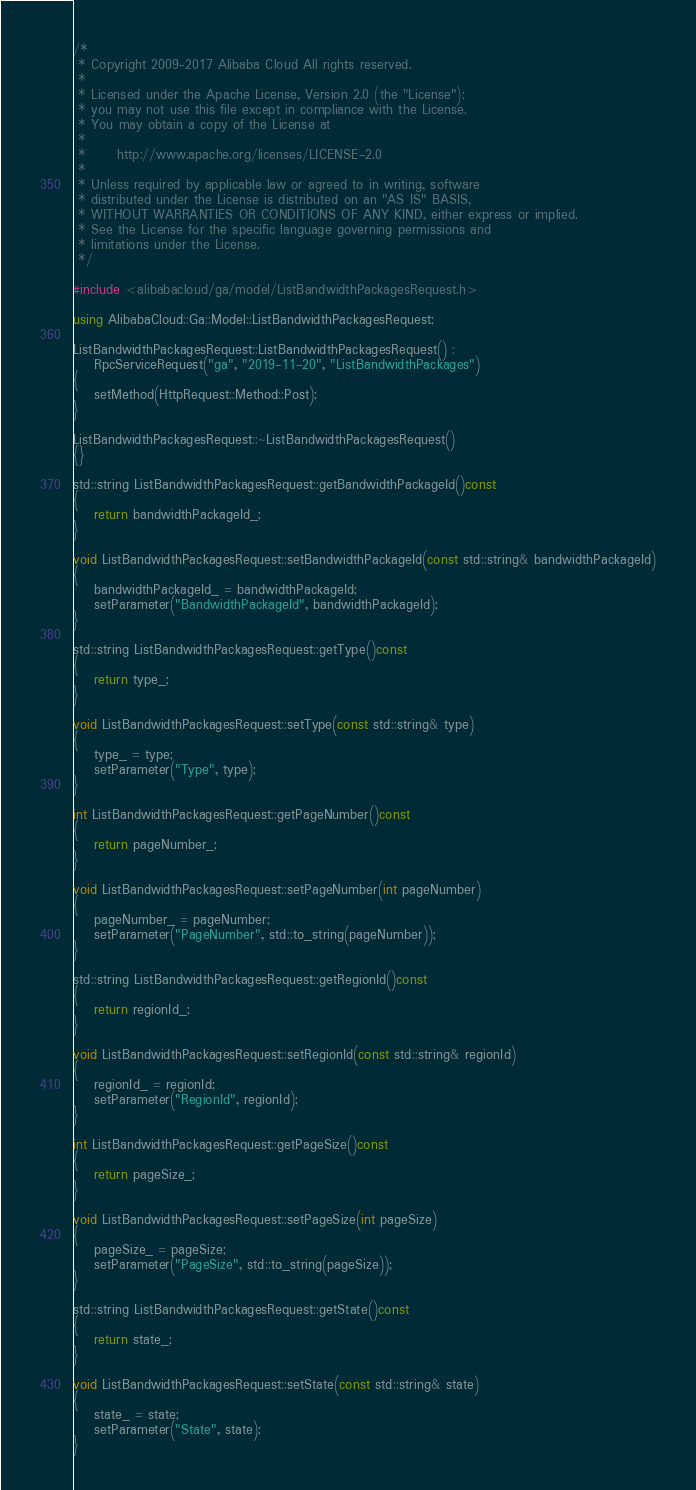<code> <loc_0><loc_0><loc_500><loc_500><_C++_>/*
 * Copyright 2009-2017 Alibaba Cloud All rights reserved.
 * 
 * Licensed under the Apache License, Version 2.0 (the "License");
 * you may not use this file except in compliance with the License.
 * You may obtain a copy of the License at
 * 
 *      http://www.apache.org/licenses/LICENSE-2.0
 * 
 * Unless required by applicable law or agreed to in writing, software
 * distributed under the License is distributed on an "AS IS" BASIS,
 * WITHOUT WARRANTIES OR CONDITIONS OF ANY KIND, either express or implied.
 * See the License for the specific language governing permissions and
 * limitations under the License.
 */

#include <alibabacloud/ga/model/ListBandwidthPackagesRequest.h>

using AlibabaCloud::Ga::Model::ListBandwidthPackagesRequest;

ListBandwidthPackagesRequest::ListBandwidthPackagesRequest() :
	RpcServiceRequest("ga", "2019-11-20", "ListBandwidthPackages")
{
	setMethod(HttpRequest::Method::Post);
}

ListBandwidthPackagesRequest::~ListBandwidthPackagesRequest()
{}

std::string ListBandwidthPackagesRequest::getBandwidthPackageId()const
{
	return bandwidthPackageId_;
}

void ListBandwidthPackagesRequest::setBandwidthPackageId(const std::string& bandwidthPackageId)
{
	bandwidthPackageId_ = bandwidthPackageId;
	setParameter("BandwidthPackageId", bandwidthPackageId);
}

std::string ListBandwidthPackagesRequest::getType()const
{
	return type_;
}

void ListBandwidthPackagesRequest::setType(const std::string& type)
{
	type_ = type;
	setParameter("Type", type);
}

int ListBandwidthPackagesRequest::getPageNumber()const
{
	return pageNumber_;
}

void ListBandwidthPackagesRequest::setPageNumber(int pageNumber)
{
	pageNumber_ = pageNumber;
	setParameter("PageNumber", std::to_string(pageNumber));
}

std::string ListBandwidthPackagesRequest::getRegionId()const
{
	return regionId_;
}

void ListBandwidthPackagesRequest::setRegionId(const std::string& regionId)
{
	regionId_ = regionId;
	setParameter("RegionId", regionId);
}

int ListBandwidthPackagesRequest::getPageSize()const
{
	return pageSize_;
}

void ListBandwidthPackagesRequest::setPageSize(int pageSize)
{
	pageSize_ = pageSize;
	setParameter("PageSize", std::to_string(pageSize));
}

std::string ListBandwidthPackagesRequest::getState()const
{
	return state_;
}

void ListBandwidthPackagesRequest::setState(const std::string& state)
{
	state_ = state;
	setParameter("State", state);
}

</code> 